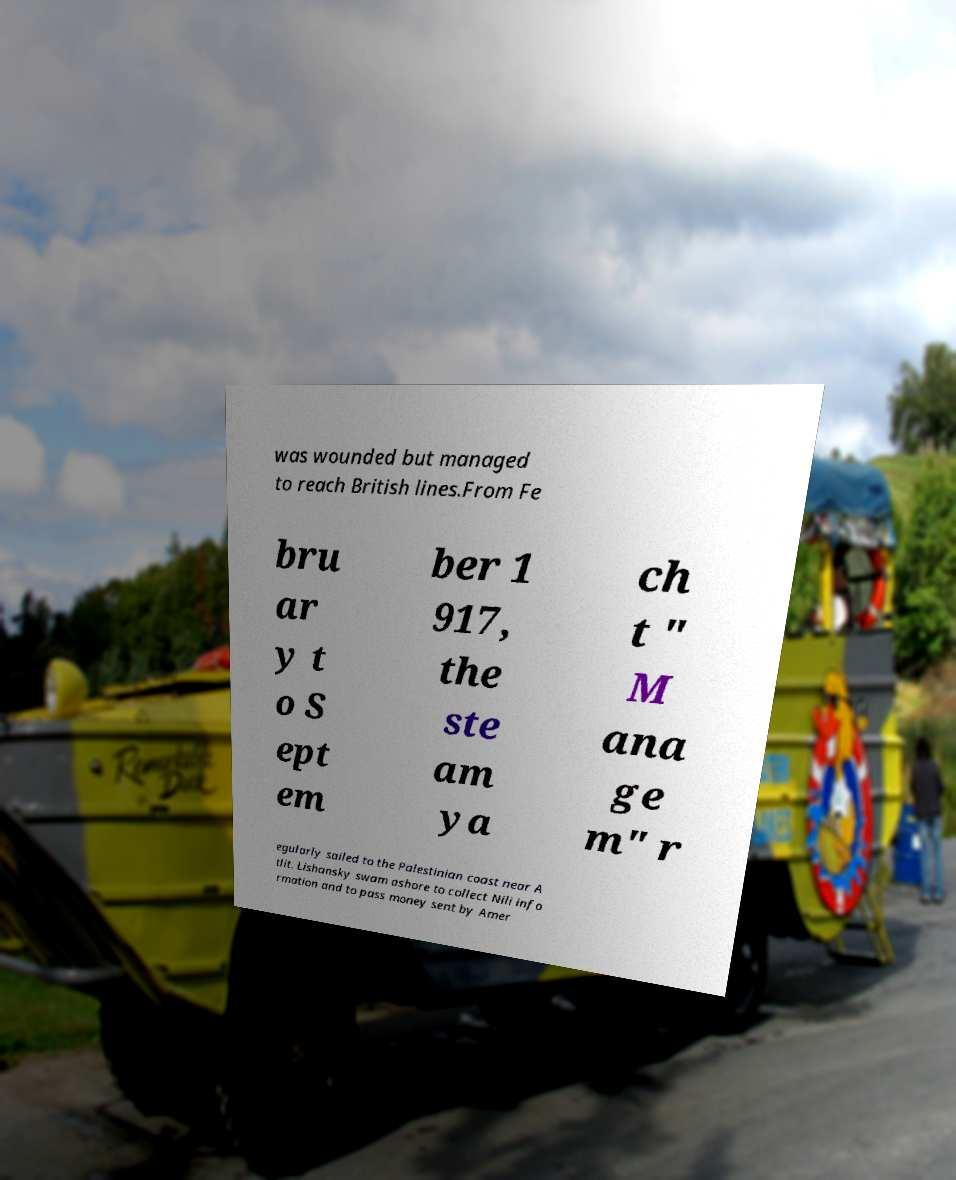Please read and relay the text visible in this image. What does it say? was wounded but managed to reach British lines.From Fe bru ar y t o S ept em ber 1 917, the ste am ya ch t " M ana ge m" r egularly sailed to the Palestinian coast near A tlit. Lishansky swam ashore to collect Nili info rmation and to pass money sent by Amer 